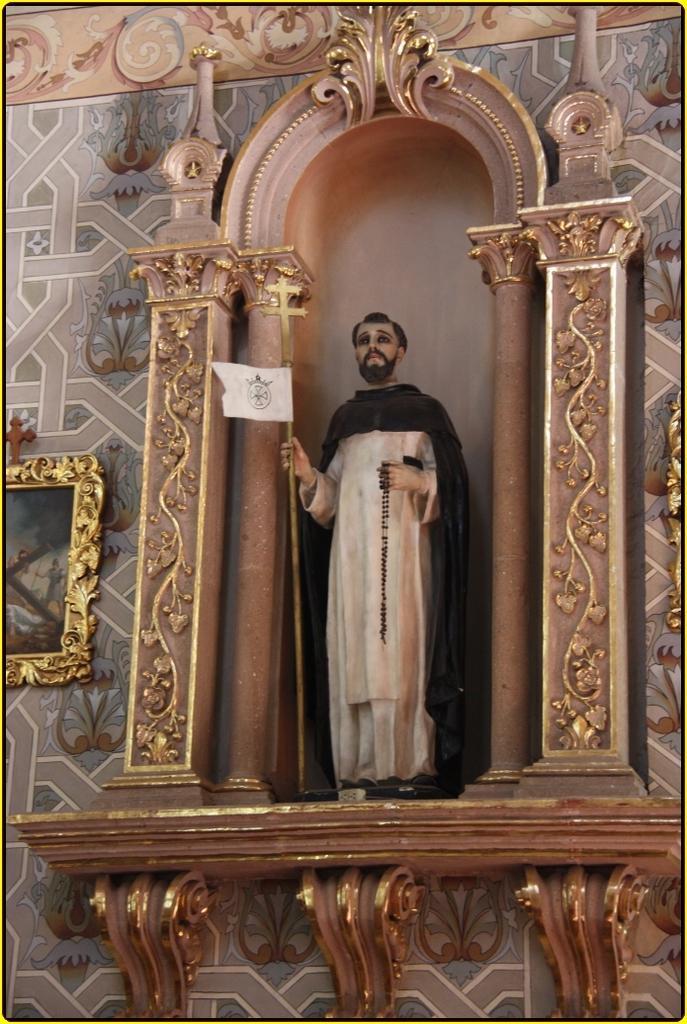In one or two sentences, can you explain what this image depicts? In this image I can see a person statute and holding something. I can see few frames attached to the colorful wall. 